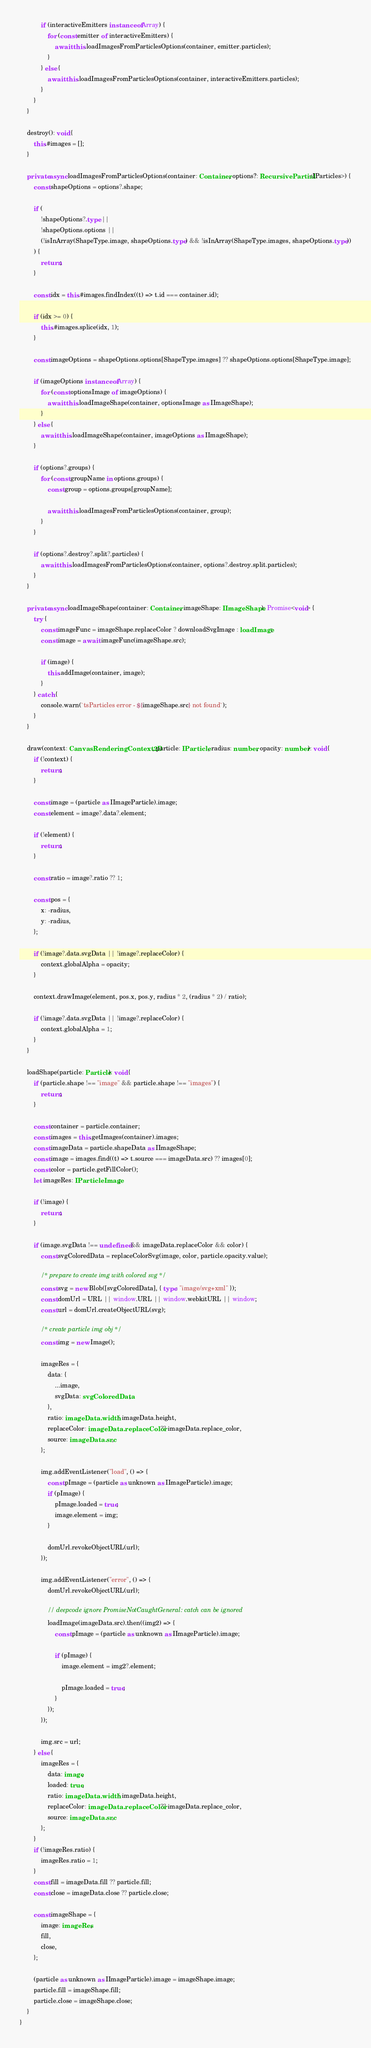Convert code to text. <code><loc_0><loc_0><loc_500><loc_500><_TypeScript_>            if (interactiveEmitters instanceof Array) {
                for (const emitter of interactiveEmitters) {
                    await this.loadImagesFromParticlesOptions(container, emitter.particles);
                }
            } else {
                await this.loadImagesFromParticlesOptions(container, interactiveEmitters.particles);
            }
        }
    }

    destroy(): void {
        this.#images = [];
    }

    private async loadImagesFromParticlesOptions(container: Container, options?: RecursivePartial<IParticles>) {
        const shapeOptions = options?.shape;

        if (
            !shapeOptions?.type ||
            !shapeOptions.options ||
            (!isInArray(ShapeType.image, shapeOptions.type) && !isInArray(ShapeType.images, shapeOptions.type))
        ) {
            return;
        }

        const idx = this.#images.findIndex((t) => t.id === container.id);

        if (idx >= 0) {
            this.#images.splice(idx, 1);
        }

        const imageOptions = shapeOptions.options[ShapeType.images] ?? shapeOptions.options[ShapeType.image];

        if (imageOptions instanceof Array) {
            for (const optionsImage of imageOptions) {
                await this.loadImageShape(container, optionsImage as IImageShape);
            }
        } else {
            await this.loadImageShape(container, imageOptions as IImageShape);
        }

        if (options?.groups) {
            for (const groupName in options.groups) {
                const group = options.groups[groupName];

                await this.loadImagesFromParticlesOptions(container, group);
            }
        }

        if (options?.destroy?.split?.particles) {
            await this.loadImagesFromParticlesOptions(container, options?.destroy.split.particles);
        }
    }

    private async loadImageShape(container: Container, imageShape: IImageShape): Promise<void> {
        try {
            const imageFunc = imageShape.replaceColor ? downloadSvgImage : loadImage;
            const image = await imageFunc(imageShape.src);

            if (image) {
                this.addImage(container, image);
            }
        } catch {
            console.warn(`tsParticles error - ${imageShape.src} not found`);
        }
    }

    draw(context: CanvasRenderingContext2D, particle: IParticle, radius: number, opacity: number): void {
        if (!context) {
            return;
        }

        const image = (particle as IImageParticle).image;
        const element = image?.data?.element;

        if (!element) {
            return;
        }

        const ratio = image?.ratio ?? 1;

        const pos = {
            x: -radius,
            y: -radius,
        };

        if (!image?.data.svgData || !image?.replaceColor) {
            context.globalAlpha = opacity;
        }

        context.drawImage(element, pos.x, pos.y, radius * 2, (radius * 2) / ratio);

        if (!image?.data.svgData || !image?.replaceColor) {
            context.globalAlpha = 1;
        }
    }

    loadShape(particle: Particle): void {
        if (particle.shape !== "image" && particle.shape !== "images") {
            return;
        }

        const container = particle.container;
        const images = this.getImages(container).images;
        const imageData = particle.shapeData as IImageShape;
        const image = images.find((t) => t.source === imageData.src) ?? images[0];
        const color = particle.getFillColor();
        let imageRes: IParticleImage;

        if (!image) {
            return;
        }

        if (image.svgData !== undefined && imageData.replaceColor && color) {
            const svgColoredData = replaceColorSvg(image, color, particle.opacity.value);

            /* prepare to create img with colored svg */
            const svg = new Blob([svgColoredData], { type: "image/svg+xml" });
            const domUrl = URL || window.URL || window.webkitURL || window;
            const url = domUrl.createObjectURL(svg);

            /* create particle img obj */
            const img = new Image();

            imageRes = {
                data: {
                    ...image,
                    svgData: svgColoredData,
                },
                ratio: imageData.width / imageData.height,
                replaceColor: imageData.replaceColor ?? imageData.replace_color,
                source: imageData.src,
            };

            img.addEventListener("load", () => {
                const pImage = (particle as unknown as IImageParticle).image;
                if (pImage) {
                    pImage.loaded = true;
                    image.element = img;
                }

                domUrl.revokeObjectURL(url);
            });

            img.addEventListener("error", () => {
                domUrl.revokeObjectURL(url);

                // deepcode ignore PromiseNotCaughtGeneral: catch can be ignored
                loadImage(imageData.src).then((img2) => {
                    const pImage = (particle as unknown as IImageParticle).image;

                    if (pImage) {
                        image.element = img2?.element;

                        pImage.loaded = true;
                    }
                });
            });

            img.src = url;
        } else {
            imageRes = {
                data: image,
                loaded: true,
                ratio: imageData.width / imageData.height,
                replaceColor: imageData.replaceColor ?? imageData.replace_color,
                source: imageData.src,
            };
        }
        if (!imageRes.ratio) {
            imageRes.ratio = 1;
        }
        const fill = imageData.fill ?? particle.fill;
        const close = imageData.close ?? particle.close;

        const imageShape = {
            image: imageRes,
            fill,
            close,
        };

        (particle as unknown as IImageParticle).image = imageShape.image;
        particle.fill = imageShape.fill;
        particle.close = imageShape.close;
    }
}
</code> 